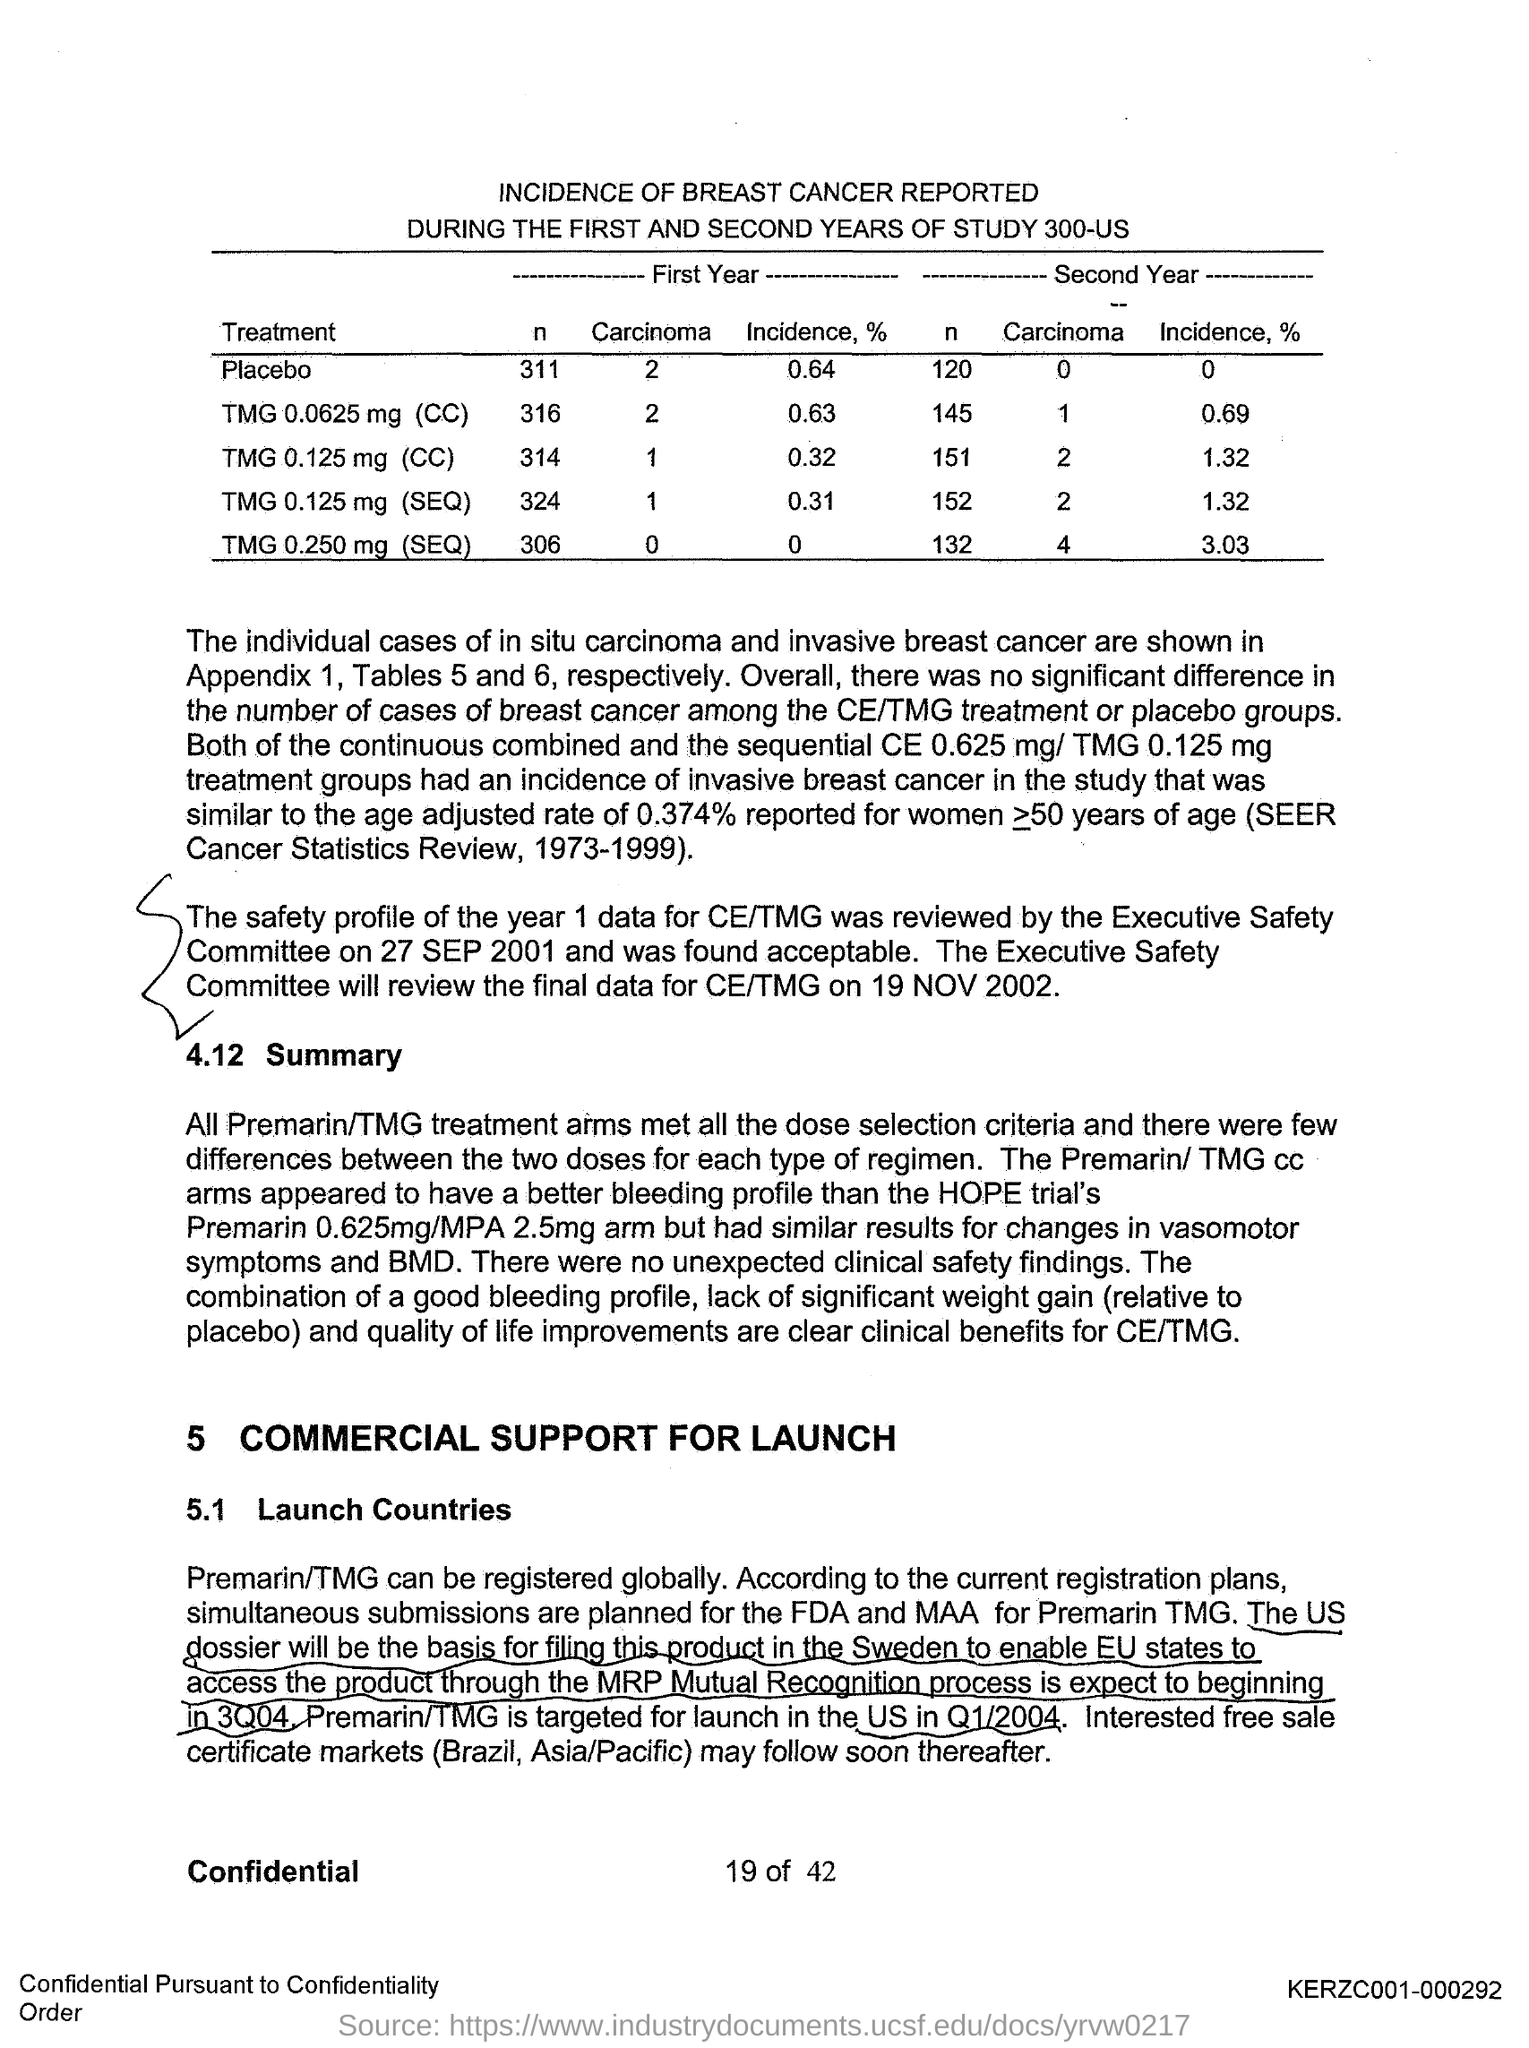Indicate a few pertinent items in this graphic. During the first year of the study, 311 individuals underwent a placebo treatment. During the second year of the study, 120 participants received a placebo treatment. 